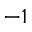<formula> <loc_0><loc_0><loc_500><loc_500>^ { - 1 }</formula> 